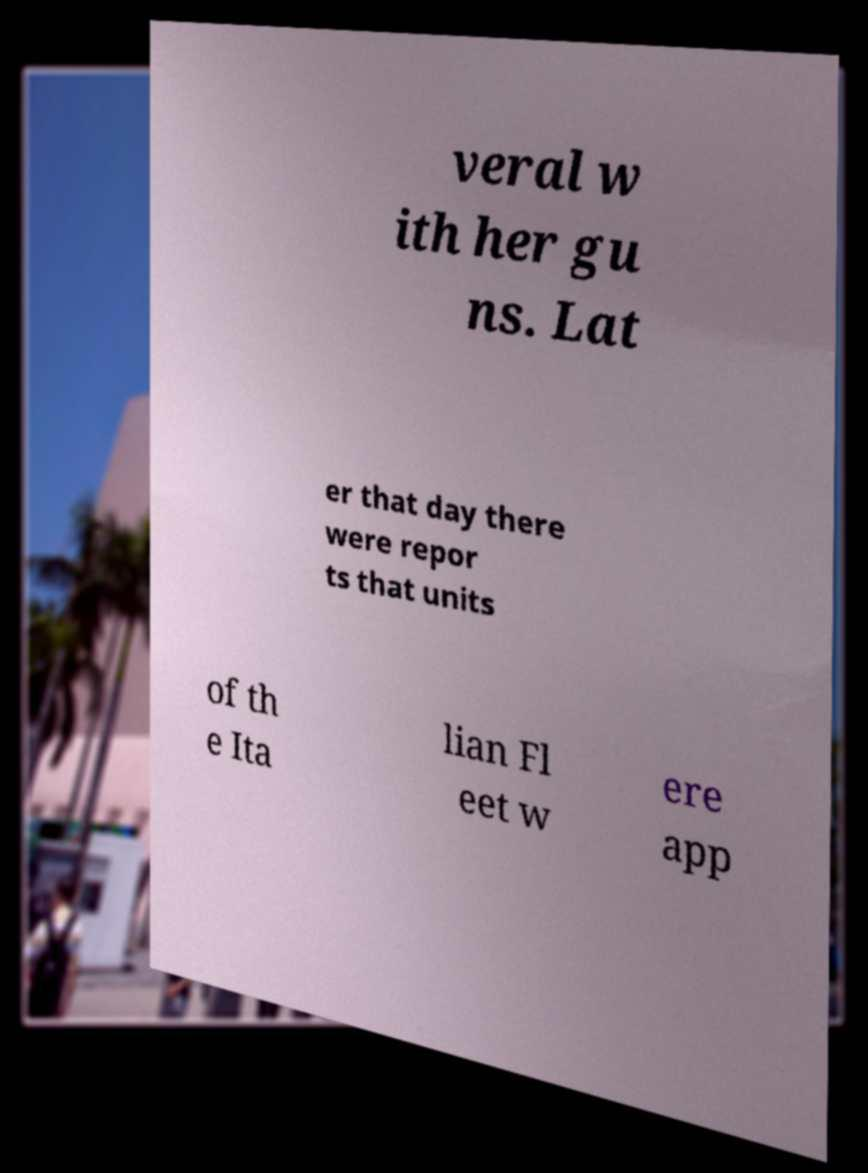What messages or text are displayed in this image? I need them in a readable, typed format. veral w ith her gu ns. Lat er that day there were repor ts that units of th e Ita lian Fl eet w ere app 